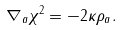Convert formula to latex. <formula><loc_0><loc_0><loc_500><loc_500>\nabla _ { a } \chi ^ { 2 } = - 2 \kappa \rho _ { a } .</formula> 